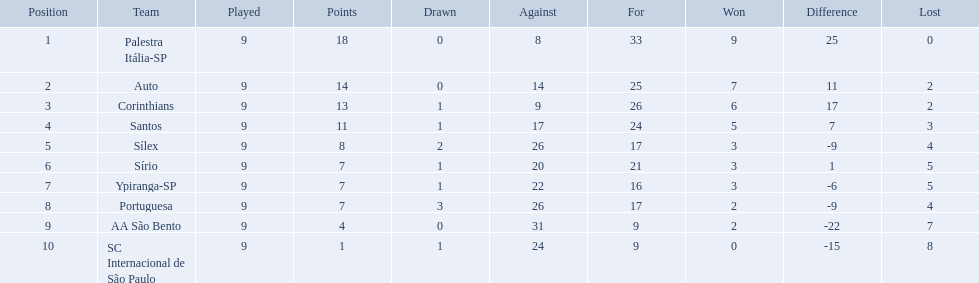Which teams were playing brazilian football in 1926? Palestra Itália-SP, Auto, Corinthians, Santos, Sílex, Sírio, Ypiranga-SP, Portuguesa, AA São Bento, SC Internacional de São Paulo. Of those teams, which one scored 13 points? Corinthians. 